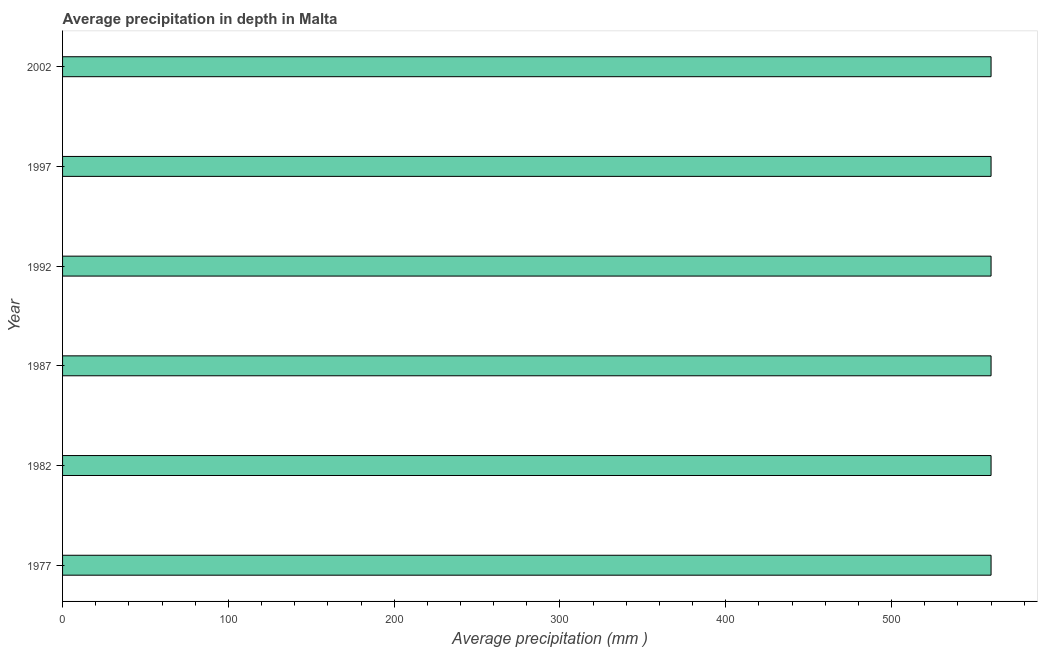What is the title of the graph?
Provide a succinct answer. Average precipitation in depth in Malta. What is the label or title of the X-axis?
Your answer should be very brief. Average precipitation (mm ). What is the average precipitation in depth in 1977?
Provide a short and direct response. 560. Across all years, what is the maximum average precipitation in depth?
Make the answer very short. 560. Across all years, what is the minimum average precipitation in depth?
Ensure brevity in your answer.  560. In which year was the average precipitation in depth maximum?
Your response must be concise. 1977. What is the sum of the average precipitation in depth?
Your answer should be very brief. 3360. What is the difference between the average precipitation in depth in 1982 and 2002?
Give a very brief answer. 0. What is the average average precipitation in depth per year?
Offer a terse response. 560. What is the median average precipitation in depth?
Your response must be concise. 560. Do a majority of the years between 2002 and 1982 (inclusive) have average precipitation in depth greater than 220 mm?
Your response must be concise. Yes. Is the difference between the average precipitation in depth in 1987 and 2002 greater than the difference between any two years?
Ensure brevity in your answer.  Yes. What is the difference between the highest and the second highest average precipitation in depth?
Make the answer very short. 0. Is the sum of the average precipitation in depth in 1977 and 1987 greater than the maximum average precipitation in depth across all years?
Give a very brief answer. Yes. What is the difference between the highest and the lowest average precipitation in depth?
Give a very brief answer. 0. In how many years, is the average precipitation in depth greater than the average average precipitation in depth taken over all years?
Keep it short and to the point. 0. What is the Average precipitation (mm ) of 1977?
Provide a short and direct response. 560. What is the Average precipitation (mm ) in 1982?
Offer a terse response. 560. What is the Average precipitation (mm ) in 1987?
Your response must be concise. 560. What is the Average precipitation (mm ) of 1992?
Provide a succinct answer. 560. What is the Average precipitation (mm ) of 1997?
Your answer should be very brief. 560. What is the Average precipitation (mm ) in 2002?
Make the answer very short. 560. What is the difference between the Average precipitation (mm ) in 1977 and 1982?
Your answer should be compact. 0. What is the difference between the Average precipitation (mm ) in 1977 and 1987?
Your response must be concise. 0. What is the difference between the Average precipitation (mm ) in 1977 and 1997?
Keep it short and to the point. 0. What is the difference between the Average precipitation (mm ) in 1977 and 2002?
Your answer should be very brief. 0. What is the difference between the Average precipitation (mm ) in 1982 and 1987?
Your answer should be very brief. 0. What is the difference between the Average precipitation (mm ) in 1982 and 2002?
Keep it short and to the point. 0. What is the difference between the Average precipitation (mm ) in 1987 and 2002?
Your answer should be very brief. 0. What is the difference between the Average precipitation (mm ) in 1992 and 1997?
Your response must be concise. 0. What is the difference between the Average precipitation (mm ) in 1992 and 2002?
Provide a succinct answer. 0. What is the difference between the Average precipitation (mm ) in 1997 and 2002?
Provide a short and direct response. 0. What is the ratio of the Average precipitation (mm ) in 1977 to that in 1982?
Offer a terse response. 1. What is the ratio of the Average precipitation (mm ) in 1977 to that in 1987?
Offer a very short reply. 1. What is the ratio of the Average precipitation (mm ) in 1977 to that in 1992?
Your response must be concise. 1. What is the ratio of the Average precipitation (mm ) in 1977 to that in 2002?
Offer a terse response. 1. What is the ratio of the Average precipitation (mm ) in 1982 to that in 2002?
Ensure brevity in your answer.  1. What is the ratio of the Average precipitation (mm ) in 1987 to that in 1992?
Offer a terse response. 1. What is the ratio of the Average precipitation (mm ) in 1987 to that in 2002?
Offer a terse response. 1. What is the ratio of the Average precipitation (mm ) in 1997 to that in 2002?
Your answer should be very brief. 1. 